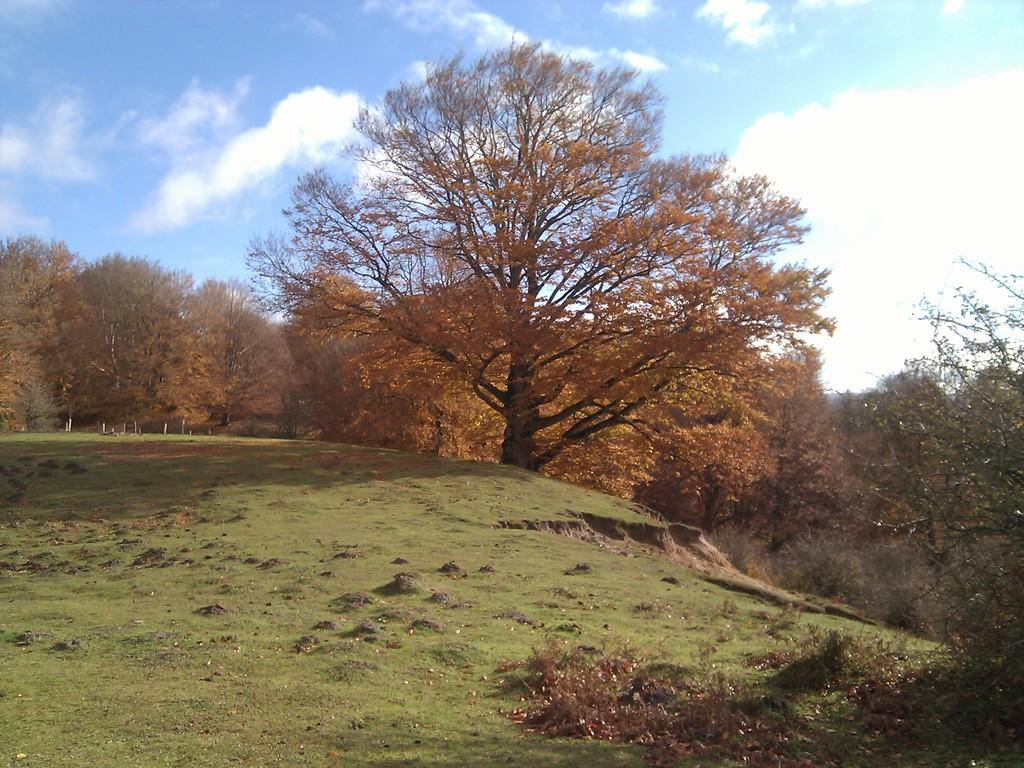What type of vegetation is at the bottom of the image? There is grass at the bottom of the image. Can you describe the location of the grass? The grass is on the surface. What can be seen in the background of the image? There are trees and the sky visible in the background of the image. What language is spoken by the beggar in the image? There is no beggar present in the image, so it is not possible to determine the language spoken. 